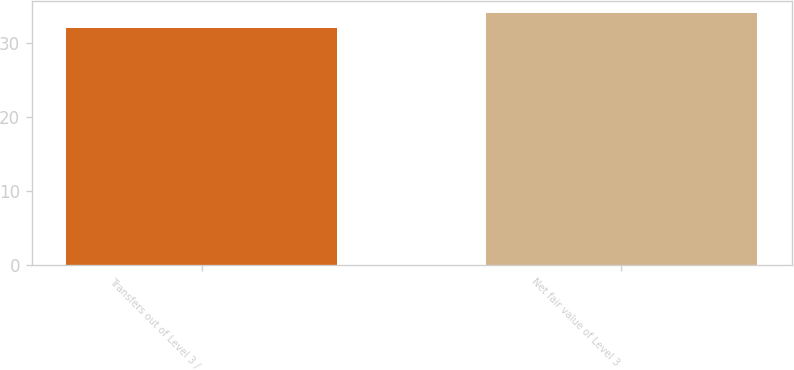<chart> <loc_0><loc_0><loc_500><loc_500><bar_chart><fcel>Transfers out of Level 3 /<fcel>Net fair value of Level 3<nl><fcel>32<fcel>34<nl></chart> 